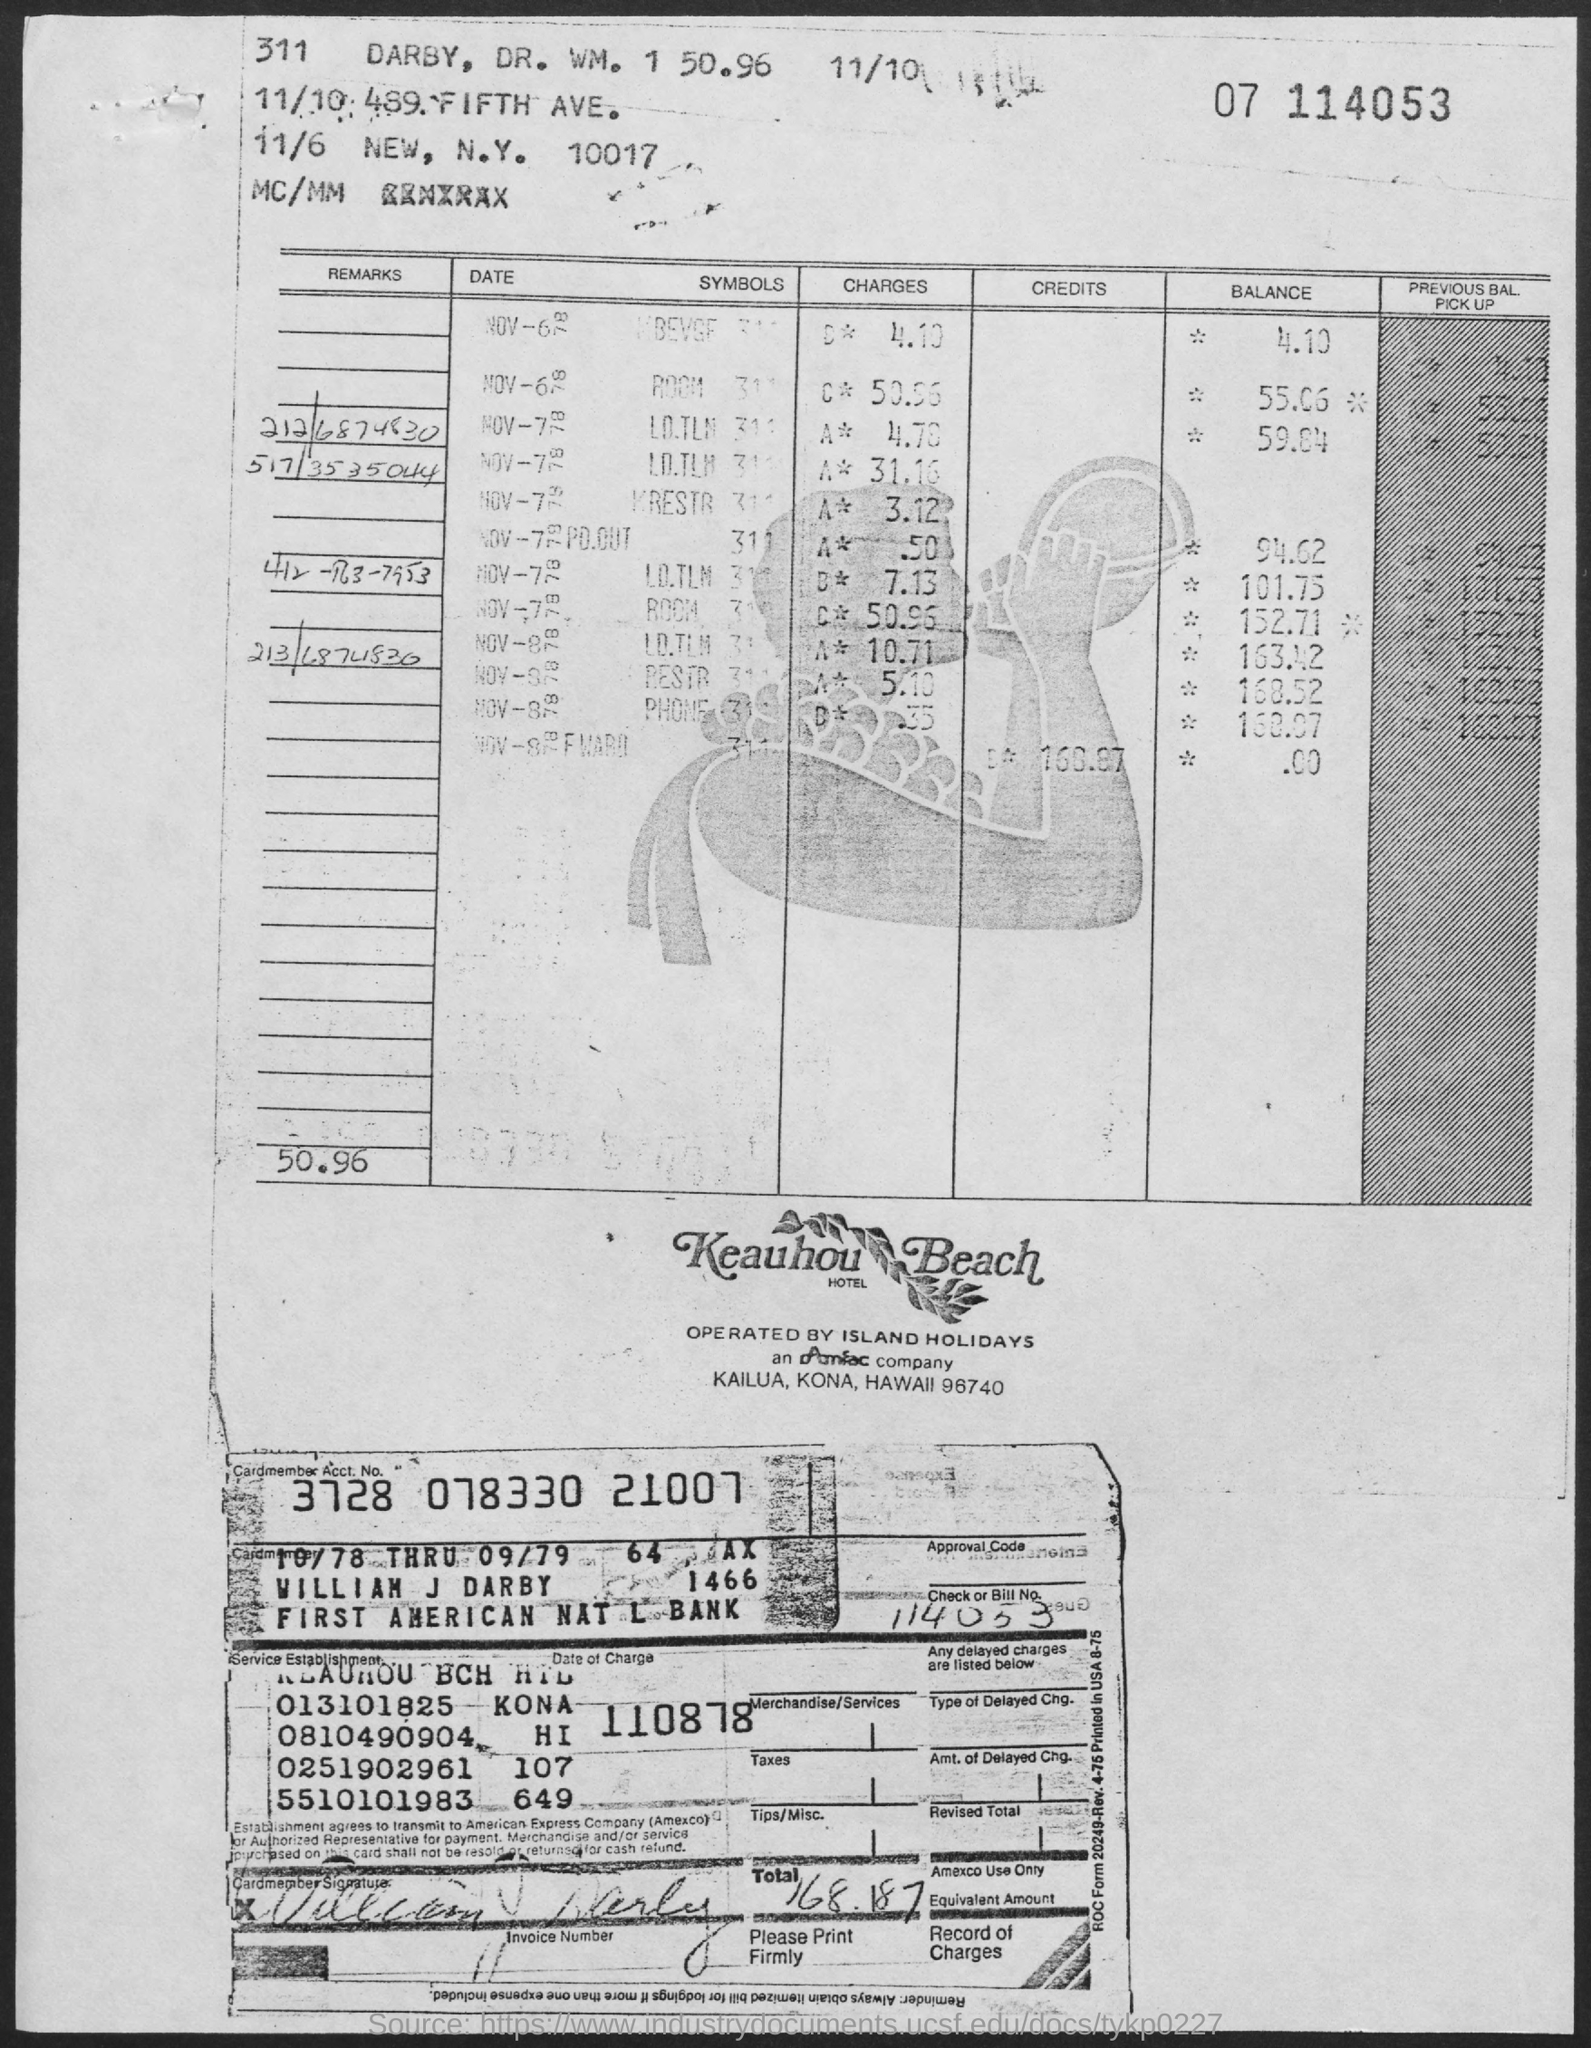Point out several critical features in this image. The Cardmember Account Number is 3728 078330 21007. The total is 168.187 and... The bill number is 114053. 